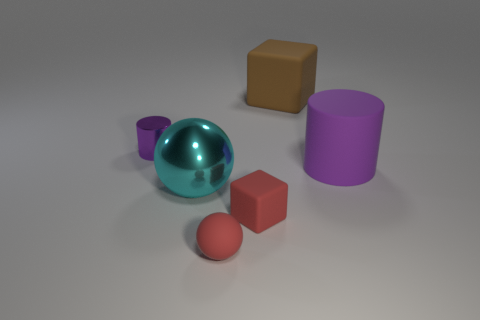What time of day does the lighting in this scene suggest? The lighting in the scene has a neutral tone and is diffusely spread, suggesting an interior setting with artificial lighting as opposed to natural sunlight. Therefore, it does not clearly indicate a specific time of day. 